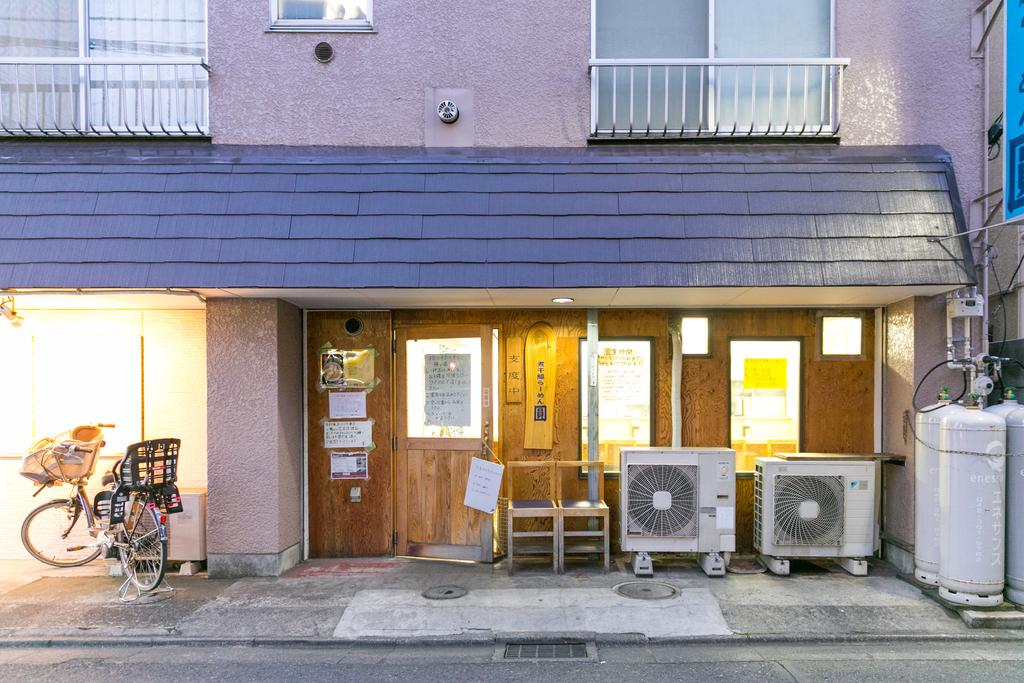What is the main structure visible in the image? There is a building in the image. What can be seen near the building? There is a bicycle parked beside the building. Are there any furniture items visible in the image? Yes, there are two chairs kept at the side near the door. What type of silk material is used to cover the bicycle in the image? There is no silk material covering the bicycle in the image; it is parked beside the building. 